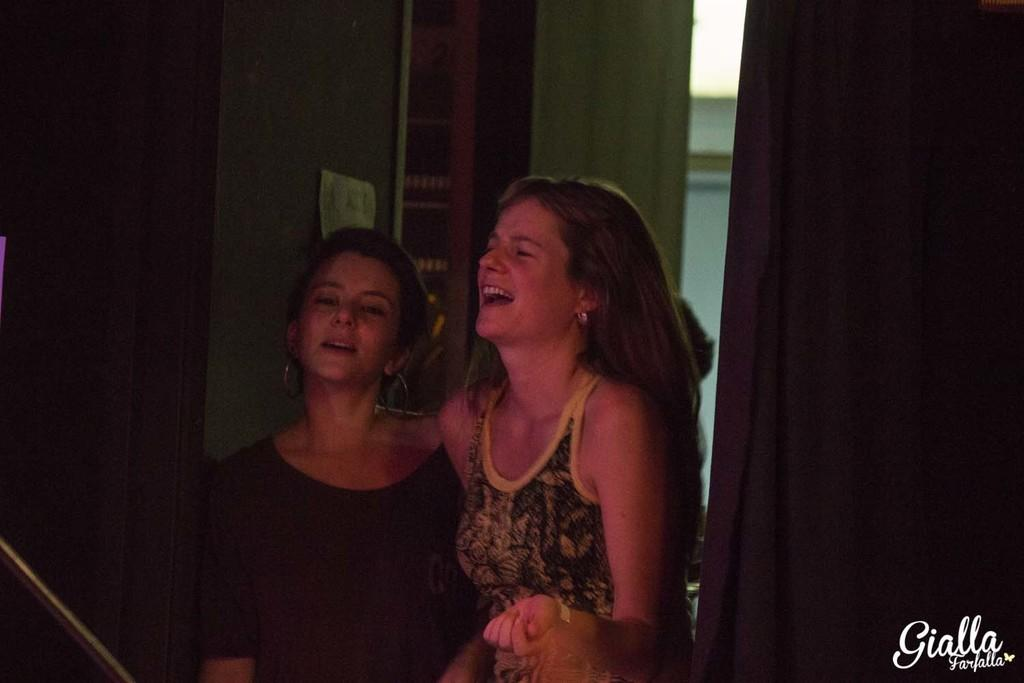How many people are present in the image? There are two women standing in the image. What can be seen in the background of the image? There is a wall in the image. Are there any objects hanging on the wall? Yes, there is a curtain in the image. What architectural feature is present in the image? There is a door in the image. What disease is the woman on the left suffering from in the image? There is no indication of any disease in the image; it only shows two women standing with a wall, curtain, and door in the background. 